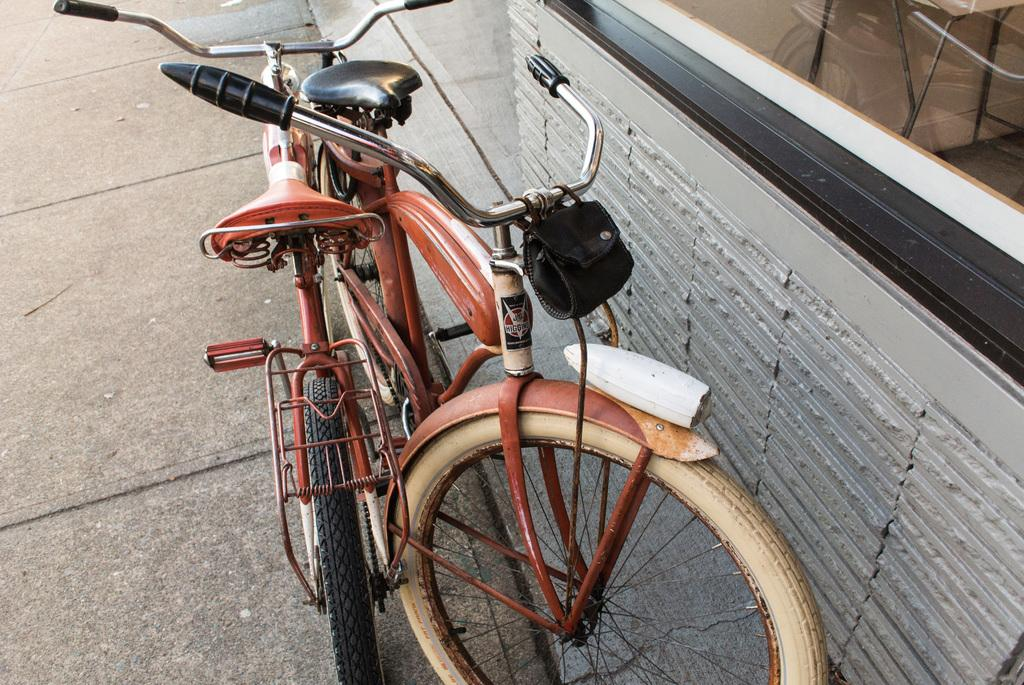How many bicycles are present in the image? There are two bicycles in the image. What else can be seen in the image besides the bicycles? There is a wall of a building in the image. What is the writer doing with the bicycles in the image? There is no writer present in the image, and no action involving the bicycles is depicted. 